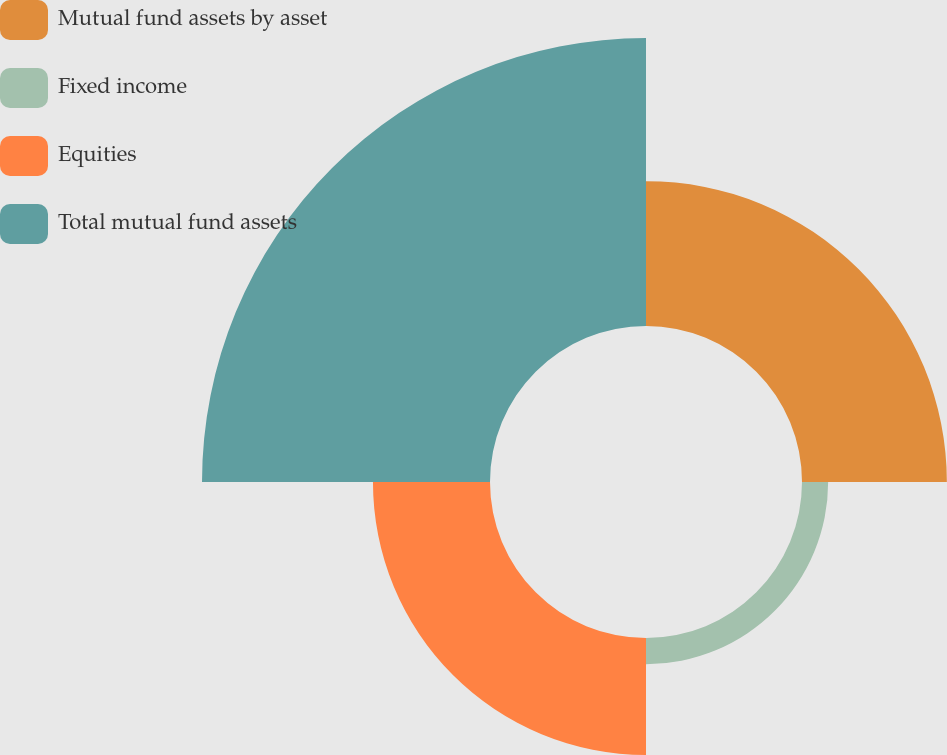Convert chart. <chart><loc_0><loc_0><loc_500><loc_500><pie_chart><fcel>Mutual fund assets by asset<fcel>Fixed income<fcel>Equities<fcel>Total mutual fund assets<nl><fcel>25.15%<fcel>4.54%<fcel>20.32%<fcel>50.0%<nl></chart> 